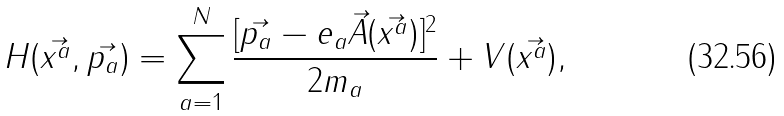Convert formula to latex. <formula><loc_0><loc_0><loc_500><loc_500>H ( \vec { x ^ { a } } , \vec { p _ { a } } ) = \sum ^ { N } _ { a = 1 } \frac { [ \vec { p _ { a } } - e _ { a } \vec { A } ( \vec { x ^ { a } } ) ] ^ { 2 } } { 2 m _ { a } } + V ( \vec { x ^ { a } } ) ,</formula> 